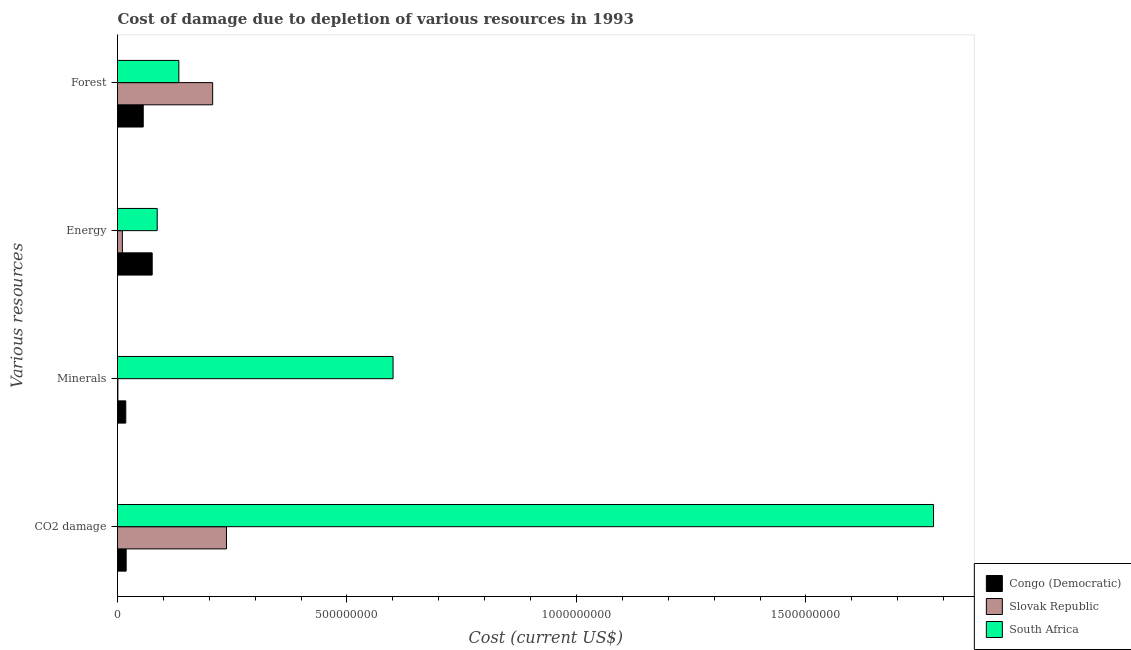How many different coloured bars are there?
Keep it short and to the point. 3. How many groups of bars are there?
Your response must be concise. 4. Are the number of bars on each tick of the Y-axis equal?
Your response must be concise. Yes. How many bars are there on the 4th tick from the top?
Your answer should be very brief. 3. How many bars are there on the 3rd tick from the bottom?
Your response must be concise. 3. What is the label of the 2nd group of bars from the top?
Keep it short and to the point. Energy. What is the cost of damage due to depletion of coal in Slovak Republic?
Your answer should be very brief. 2.37e+08. Across all countries, what is the maximum cost of damage due to depletion of minerals?
Ensure brevity in your answer.  6.00e+08. Across all countries, what is the minimum cost of damage due to depletion of coal?
Provide a succinct answer. 1.89e+07. In which country was the cost of damage due to depletion of forests maximum?
Offer a terse response. Slovak Republic. In which country was the cost of damage due to depletion of coal minimum?
Give a very brief answer. Congo (Democratic). What is the total cost of damage due to depletion of energy in the graph?
Your response must be concise. 1.73e+08. What is the difference between the cost of damage due to depletion of forests in Slovak Republic and that in South Africa?
Offer a terse response. 7.37e+07. What is the difference between the cost of damage due to depletion of forests in Slovak Republic and the cost of damage due to depletion of minerals in South Africa?
Offer a terse response. -3.93e+08. What is the average cost of damage due to depletion of coal per country?
Offer a terse response. 6.78e+08. What is the difference between the cost of damage due to depletion of energy and cost of damage due to depletion of minerals in Slovak Republic?
Make the answer very short. 9.75e+06. In how many countries, is the cost of damage due to depletion of coal greater than 500000000 US$?
Give a very brief answer. 1. What is the ratio of the cost of damage due to depletion of minerals in South Africa to that in Slovak Republic?
Offer a terse response. 703.7. What is the difference between the highest and the second highest cost of damage due to depletion of minerals?
Offer a terse response. 5.82e+08. What is the difference between the highest and the lowest cost of damage due to depletion of coal?
Give a very brief answer. 1.76e+09. In how many countries, is the cost of damage due to depletion of energy greater than the average cost of damage due to depletion of energy taken over all countries?
Offer a very short reply. 2. Is the sum of the cost of damage due to depletion of minerals in South Africa and Slovak Republic greater than the maximum cost of damage due to depletion of energy across all countries?
Offer a very short reply. Yes. What does the 3rd bar from the top in CO2 damage represents?
Make the answer very short. Congo (Democratic). What does the 2nd bar from the bottom in Forest represents?
Provide a short and direct response. Slovak Republic. How many bars are there?
Your answer should be very brief. 12. How many countries are there in the graph?
Your response must be concise. 3. What is the difference between two consecutive major ticks on the X-axis?
Your answer should be very brief. 5.00e+08. Does the graph contain any zero values?
Offer a very short reply. No. Does the graph contain grids?
Keep it short and to the point. No. Where does the legend appear in the graph?
Ensure brevity in your answer.  Bottom right. What is the title of the graph?
Offer a very short reply. Cost of damage due to depletion of various resources in 1993 . Does "United States" appear as one of the legend labels in the graph?
Your answer should be compact. No. What is the label or title of the X-axis?
Give a very brief answer. Cost (current US$). What is the label or title of the Y-axis?
Your answer should be compact. Various resources. What is the Cost (current US$) of Congo (Democratic) in CO2 damage?
Your answer should be very brief. 1.89e+07. What is the Cost (current US$) in Slovak Republic in CO2 damage?
Your answer should be compact. 2.37e+08. What is the Cost (current US$) of South Africa in CO2 damage?
Ensure brevity in your answer.  1.78e+09. What is the Cost (current US$) in Congo (Democratic) in Minerals?
Provide a short and direct response. 1.80e+07. What is the Cost (current US$) of Slovak Republic in Minerals?
Make the answer very short. 8.53e+05. What is the Cost (current US$) in South Africa in Minerals?
Make the answer very short. 6.00e+08. What is the Cost (current US$) in Congo (Democratic) in Energy?
Give a very brief answer. 7.56e+07. What is the Cost (current US$) of Slovak Republic in Energy?
Your response must be concise. 1.06e+07. What is the Cost (current US$) of South Africa in Energy?
Offer a terse response. 8.65e+07. What is the Cost (current US$) of Congo (Democratic) in Forest?
Make the answer very short. 5.61e+07. What is the Cost (current US$) in Slovak Republic in Forest?
Your answer should be compact. 2.07e+08. What is the Cost (current US$) in South Africa in Forest?
Your response must be concise. 1.34e+08. Across all Various resources, what is the maximum Cost (current US$) of Congo (Democratic)?
Your answer should be very brief. 7.56e+07. Across all Various resources, what is the maximum Cost (current US$) of Slovak Republic?
Provide a short and direct response. 2.37e+08. Across all Various resources, what is the maximum Cost (current US$) of South Africa?
Make the answer very short. 1.78e+09. Across all Various resources, what is the minimum Cost (current US$) of Congo (Democratic)?
Provide a short and direct response. 1.80e+07. Across all Various resources, what is the minimum Cost (current US$) in Slovak Republic?
Provide a succinct answer. 8.53e+05. Across all Various resources, what is the minimum Cost (current US$) of South Africa?
Provide a short and direct response. 8.65e+07. What is the total Cost (current US$) of Congo (Democratic) in the graph?
Your answer should be compact. 1.69e+08. What is the total Cost (current US$) of Slovak Republic in the graph?
Your answer should be very brief. 4.56e+08. What is the total Cost (current US$) of South Africa in the graph?
Offer a very short reply. 2.60e+09. What is the difference between the Cost (current US$) in Congo (Democratic) in CO2 damage and that in Minerals?
Make the answer very short. 8.48e+05. What is the difference between the Cost (current US$) in Slovak Republic in CO2 damage and that in Minerals?
Keep it short and to the point. 2.37e+08. What is the difference between the Cost (current US$) in South Africa in CO2 damage and that in Minerals?
Offer a terse response. 1.18e+09. What is the difference between the Cost (current US$) in Congo (Democratic) in CO2 damage and that in Energy?
Provide a short and direct response. -5.67e+07. What is the difference between the Cost (current US$) of Slovak Republic in CO2 damage and that in Energy?
Your answer should be compact. 2.27e+08. What is the difference between the Cost (current US$) of South Africa in CO2 damage and that in Energy?
Your response must be concise. 1.69e+09. What is the difference between the Cost (current US$) of Congo (Democratic) in CO2 damage and that in Forest?
Make the answer very short. -3.72e+07. What is the difference between the Cost (current US$) of Slovak Republic in CO2 damage and that in Forest?
Your answer should be very brief. 3.01e+07. What is the difference between the Cost (current US$) of South Africa in CO2 damage and that in Forest?
Give a very brief answer. 1.64e+09. What is the difference between the Cost (current US$) of Congo (Democratic) in Minerals and that in Energy?
Offer a very short reply. -5.75e+07. What is the difference between the Cost (current US$) in Slovak Republic in Minerals and that in Energy?
Keep it short and to the point. -9.75e+06. What is the difference between the Cost (current US$) of South Africa in Minerals and that in Energy?
Ensure brevity in your answer.  5.14e+08. What is the difference between the Cost (current US$) in Congo (Democratic) in Minerals and that in Forest?
Your answer should be compact. -3.80e+07. What is the difference between the Cost (current US$) in Slovak Republic in Minerals and that in Forest?
Keep it short and to the point. -2.06e+08. What is the difference between the Cost (current US$) in South Africa in Minerals and that in Forest?
Offer a very short reply. 4.67e+08. What is the difference between the Cost (current US$) in Congo (Democratic) in Energy and that in Forest?
Ensure brevity in your answer.  1.95e+07. What is the difference between the Cost (current US$) in Slovak Republic in Energy and that in Forest?
Offer a terse response. -1.97e+08. What is the difference between the Cost (current US$) in South Africa in Energy and that in Forest?
Offer a very short reply. -4.72e+07. What is the difference between the Cost (current US$) of Congo (Democratic) in CO2 damage and the Cost (current US$) of Slovak Republic in Minerals?
Provide a succinct answer. 1.80e+07. What is the difference between the Cost (current US$) of Congo (Democratic) in CO2 damage and the Cost (current US$) of South Africa in Minerals?
Your answer should be very brief. -5.82e+08. What is the difference between the Cost (current US$) in Slovak Republic in CO2 damage and the Cost (current US$) in South Africa in Minerals?
Offer a terse response. -3.63e+08. What is the difference between the Cost (current US$) of Congo (Democratic) in CO2 damage and the Cost (current US$) of Slovak Republic in Energy?
Make the answer very short. 8.28e+06. What is the difference between the Cost (current US$) in Congo (Democratic) in CO2 damage and the Cost (current US$) in South Africa in Energy?
Make the answer very short. -6.76e+07. What is the difference between the Cost (current US$) of Slovak Republic in CO2 damage and the Cost (current US$) of South Africa in Energy?
Make the answer very short. 1.51e+08. What is the difference between the Cost (current US$) in Congo (Democratic) in CO2 damage and the Cost (current US$) in Slovak Republic in Forest?
Your response must be concise. -1.88e+08. What is the difference between the Cost (current US$) of Congo (Democratic) in CO2 damage and the Cost (current US$) of South Africa in Forest?
Offer a terse response. -1.15e+08. What is the difference between the Cost (current US$) of Slovak Republic in CO2 damage and the Cost (current US$) of South Africa in Forest?
Your response must be concise. 1.04e+08. What is the difference between the Cost (current US$) of Congo (Democratic) in Minerals and the Cost (current US$) of Slovak Republic in Energy?
Ensure brevity in your answer.  7.44e+06. What is the difference between the Cost (current US$) in Congo (Democratic) in Minerals and the Cost (current US$) in South Africa in Energy?
Ensure brevity in your answer.  -6.85e+07. What is the difference between the Cost (current US$) in Slovak Republic in Minerals and the Cost (current US$) in South Africa in Energy?
Keep it short and to the point. -8.56e+07. What is the difference between the Cost (current US$) in Congo (Democratic) in Minerals and the Cost (current US$) in Slovak Republic in Forest?
Provide a short and direct response. -1.89e+08. What is the difference between the Cost (current US$) in Congo (Democratic) in Minerals and the Cost (current US$) in South Africa in Forest?
Ensure brevity in your answer.  -1.16e+08. What is the difference between the Cost (current US$) of Slovak Republic in Minerals and the Cost (current US$) of South Africa in Forest?
Ensure brevity in your answer.  -1.33e+08. What is the difference between the Cost (current US$) in Congo (Democratic) in Energy and the Cost (current US$) in Slovak Republic in Forest?
Your answer should be very brief. -1.32e+08. What is the difference between the Cost (current US$) of Congo (Democratic) in Energy and the Cost (current US$) of South Africa in Forest?
Your answer should be compact. -5.81e+07. What is the difference between the Cost (current US$) in Slovak Republic in Energy and the Cost (current US$) in South Africa in Forest?
Give a very brief answer. -1.23e+08. What is the average Cost (current US$) in Congo (Democratic) per Various resources?
Provide a short and direct response. 4.21e+07. What is the average Cost (current US$) of Slovak Republic per Various resources?
Offer a terse response. 1.14e+08. What is the average Cost (current US$) of South Africa per Various resources?
Offer a terse response. 6.50e+08. What is the difference between the Cost (current US$) in Congo (Democratic) and Cost (current US$) in Slovak Republic in CO2 damage?
Provide a succinct answer. -2.19e+08. What is the difference between the Cost (current US$) of Congo (Democratic) and Cost (current US$) of South Africa in CO2 damage?
Your response must be concise. -1.76e+09. What is the difference between the Cost (current US$) of Slovak Republic and Cost (current US$) of South Africa in CO2 damage?
Your answer should be very brief. -1.54e+09. What is the difference between the Cost (current US$) in Congo (Democratic) and Cost (current US$) in Slovak Republic in Minerals?
Your response must be concise. 1.72e+07. What is the difference between the Cost (current US$) in Congo (Democratic) and Cost (current US$) in South Africa in Minerals?
Your answer should be very brief. -5.82e+08. What is the difference between the Cost (current US$) of Slovak Republic and Cost (current US$) of South Africa in Minerals?
Provide a short and direct response. -6.00e+08. What is the difference between the Cost (current US$) in Congo (Democratic) and Cost (current US$) in Slovak Republic in Energy?
Provide a short and direct response. 6.50e+07. What is the difference between the Cost (current US$) of Congo (Democratic) and Cost (current US$) of South Africa in Energy?
Your response must be concise. -1.09e+07. What is the difference between the Cost (current US$) in Slovak Republic and Cost (current US$) in South Africa in Energy?
Keep it short and to the point. -7.59e+07. What is the difference between the Cost (current US$) of Congo (Democratic) and Cost (current US$) of Slovak Republic in Forest?
Offer a terse response. -1.51e+08. What is the difference between the Cost (current US$) of Congo (Democratic) and Cost (current US$) of South Africa in Forest?
Provide a succinct answer. -7.76e+07. What is the difference between the Cost (current US$) of Slovak Republic and Cost (current US$) of South Africa in Forest?
Keep it short and to the point. 7.37e+07. What is the ratio of the Cost (current US$) of Congo (Democratic) in CO2 damage to that in Minerals?
Offer a very short reply. 1.05. What is the ratio of the Cost (current US$) in Slovak Republic in CO2 damage to that in Minerals?
Your answer should be very brief. 278.3. What is the ratio of the Cost (current US$) of South Africa in CO2 damage to that in Minerals?
Provide a succinct answer. 2.96. What is the ratio of the Cost (current US$) in Congo (Democratic) in CO2 damage to that in Energy?
Make the answer very short. 0.25. What is the ratio of the Cost (current US$) in Slovak Republic in CO2 damage to that in Energy?
Give a very brief answer. 22.4. What is the ratio of the Cost (current US$) in South Africa in CO2 damage to that in Energy?
Offer a very short reply. 20.56. What is the ratio of the Cost (current US$) in Congo (Democratic) in CO2 damage to that in Forest?
Keep it short and to the point. 0.34. What is the ratio of the Cost (current US$) in Slovak Republic in CO2 damage to that in Forest?
Offer a very short reply. 1.15. What is the ratio of the Cost (current US$) in South Africa in CO2 damage to that in Forest?
Offer a terse response. 13.3. What is the ratio of the Cost (current US$) of Congo (Democratic) in Minerals to that in Energy?
Keep it short and to the point. 0.24. What is the ratio of the Cost (current US$) of Slovak Republic in Minerals to that in Energy?
Offer a terse response. 0.08. What is the ratio of the Cost (current US$) in South Africa in Minerals to that in Energy?
Offer a very short reply. 6.94. What is the ratio of the Cost (current US$) in Congo (Democratic) in Minerals to that in Forest?
Your answer should be compact. 0.32. What is the ratio of the Cost (current US$) in Slovak Republic in Minerals to that in Forest?
Your response must be concise. 0. What is the ratio of the Cost (current US$) of South Africa in Minerals to that in Forest?
Offer a terse response. 4.49. What is the ratio of the Cost (current US$) of Congo (Democratic) in Energy to that in Forest?
Make the answer very short. 1.35. What is the ratio of the Cost (current US$) in Slovak Republic in Energy to that in Forest?
Give a very brief answer. 0.05. What is the ratio of the Cost (current US$) of South Africa in Energy to that in Forest?
Make the answer very short. 0.65. What is the difference between the highest and the second highest Cost (current US$) of Congo (Democratic)?
Your response must be concise. 1.95e+07. What is the difference between the highest and the second highest Cost (current US$) of Slovak Republic?
Your response must be concise. 3.01e+07. What is the difference between the highest and the second highest Cost (current US$) of South Africa?
Offer a terse response. 1.18e+09. What is the difference between the highest and the lowest Cost (current US$) of Congo (Democratic)?
Provide a short and direct response. 5.75e+07. What is the difference between the highest and the lowest Cost (current US$) of Slovak Republic?
Your answer should be compact. 2.37e+08. What is the difference between the highest and the lowest Cost (current US$) in South Africa?
Provide a succinct answer. 1.69e+09. 